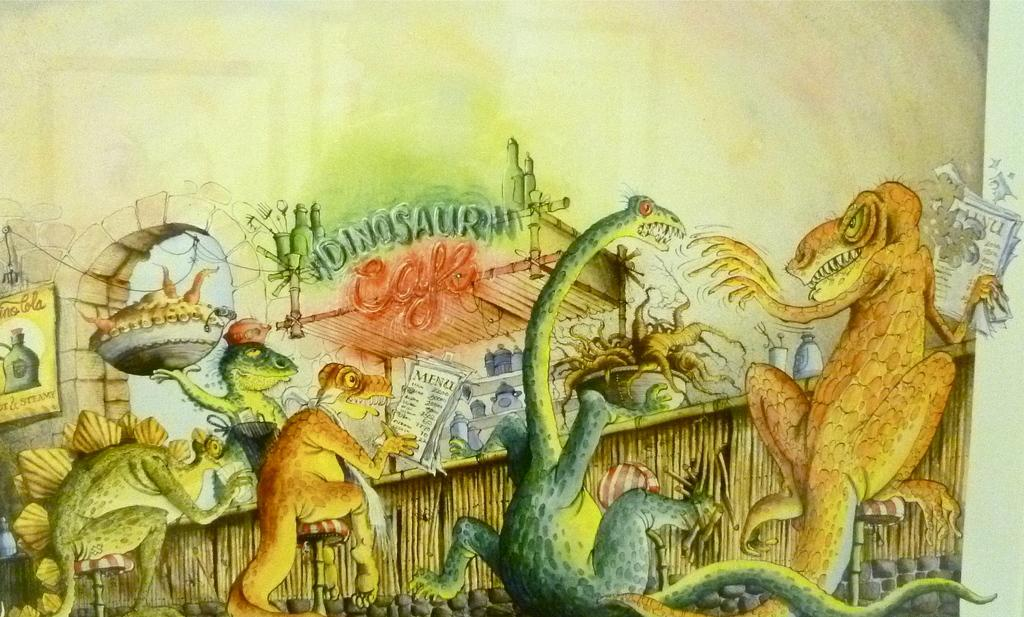What is the main subject of the image? The main subject of the image is a city. Can you describe any specific features of the city? Unfortunately, the provided facts do not give any specific details about the city. Are there any natural elements visible in the image? The facts do not mention any natural elements in the image. What is the weather like in the image? The facts do not provide any information about the weather in the image. How many births are taking place in the city in the image? There is no information about births or any specific events happening in the city in the image. What type of fowl can be seen flying over the city in the image? There is no mention of any fowl or birds in the image. 